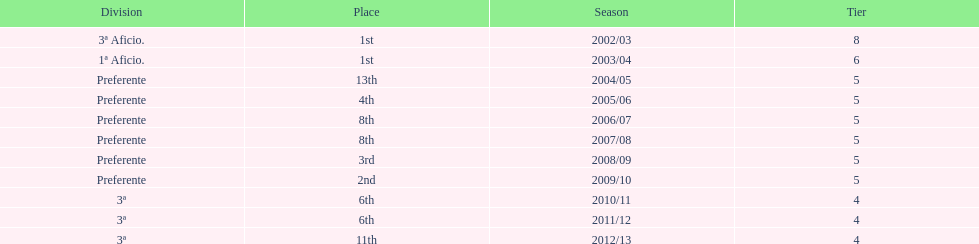In what year did the team achieve the same place as 2010/11? 2011/12. 